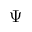Convert formula to latex. <formula><loc_0><loc_0><loc_500><loc_500>\Psi</formula> 